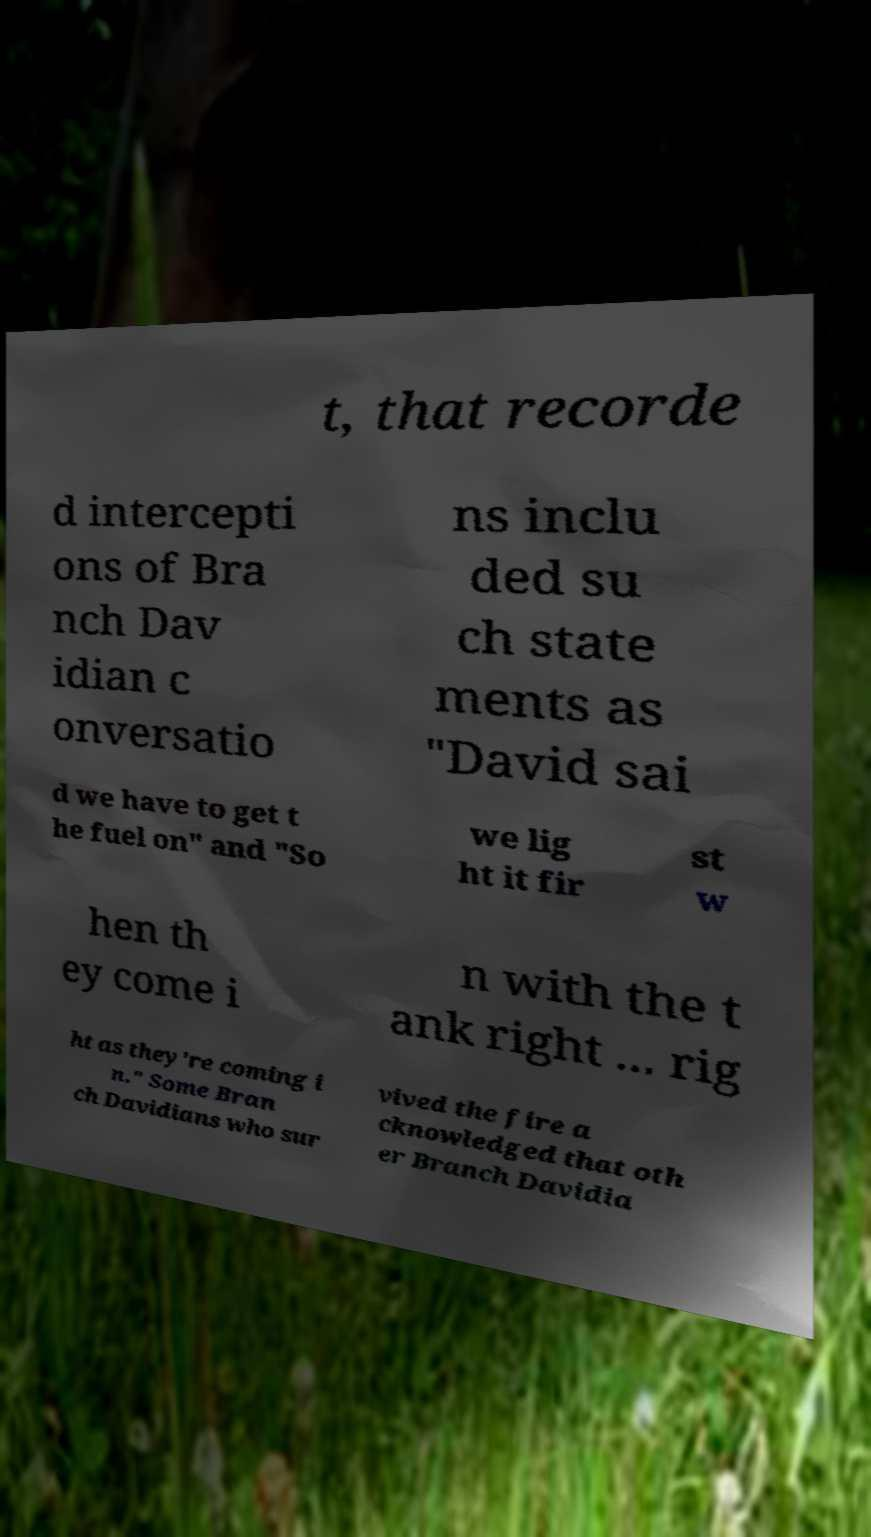Please identify and transcribe the text found in this image. t, that recorde d intercepti ons of Bra nch Dav idian c onversatio ns inclu ded su ch state ments as "David sai d we have to get t he fuel on" and "So we lig ht it fir st w hen th ey come i n with the t ank right ... rig ht as they're coming i n." Some Bran ch Davidians who sur vived the fire a cknowledged that oth er Branch Davidia 